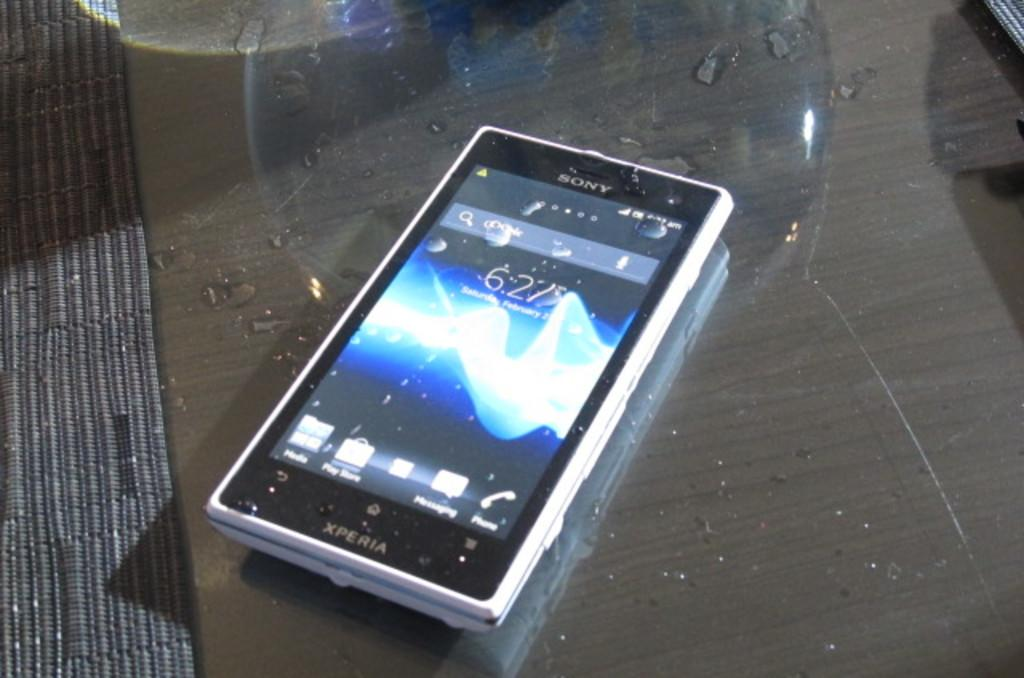<image>
Render a clear and concise summary of the photo. The Xperia line of cell phones is manufactured by Sony. 